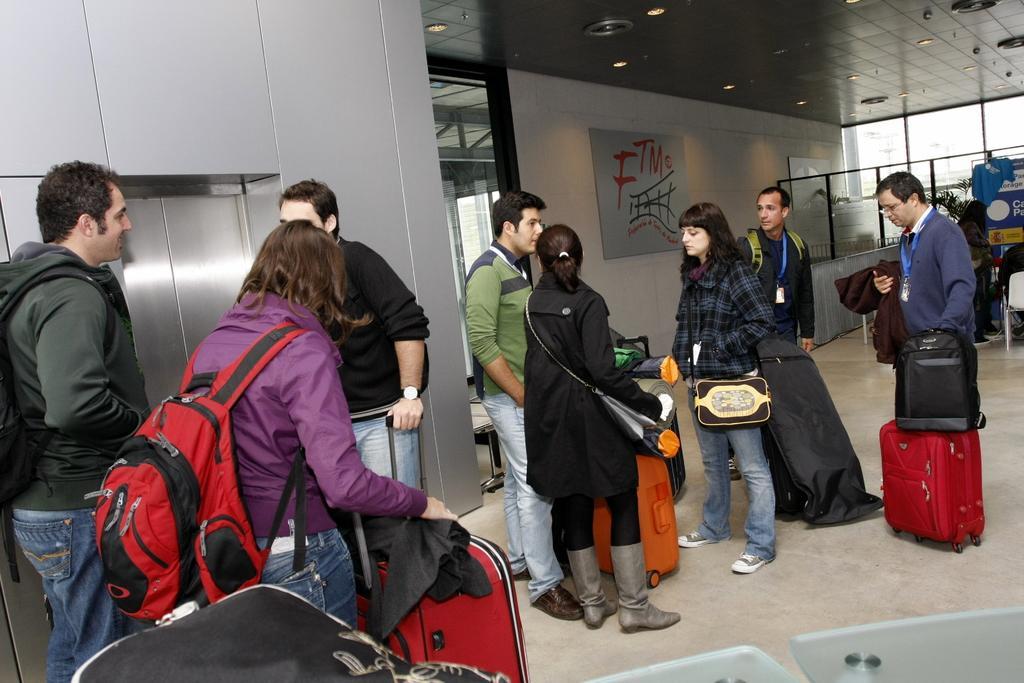Describe this image in one or two sentences. In this image i can see a group of people standing ,few of them are wearing bags and holding suitcases in their hands. In the background i can see glass windows, few lights to the ceiling. 